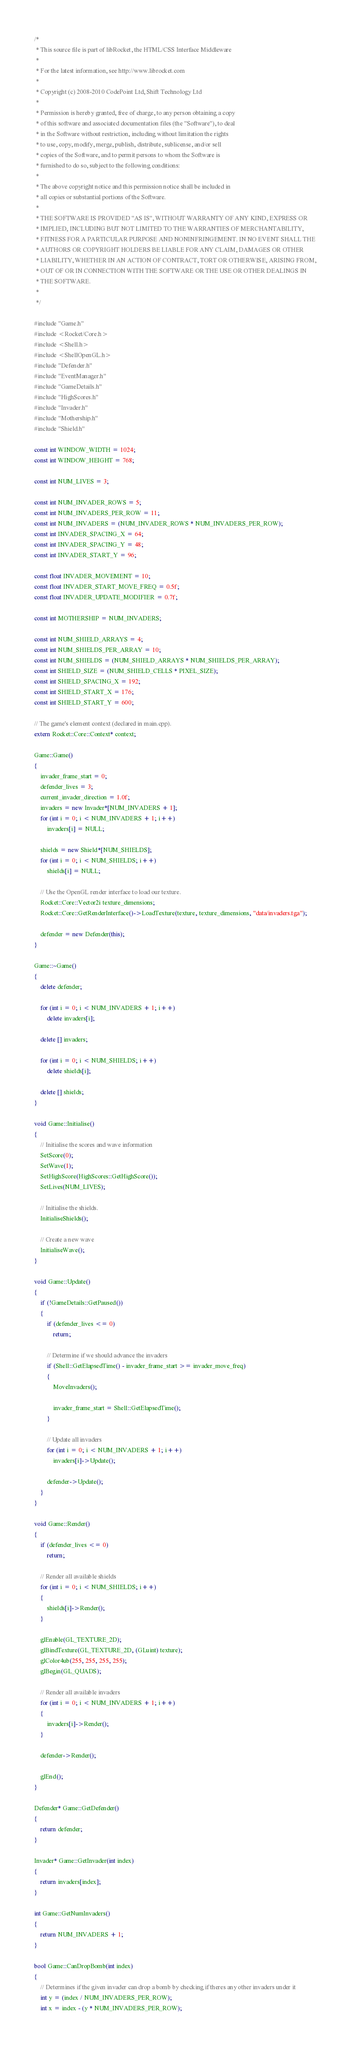<code> <loc_0><loc_0><loc_500><loc_500><_C++_>/*
 * This source file is part of libRocket, the HTML/CSS Interface Middleware
 *
 * For the latest information, see http://www.librocket.com
 *
 * Copyright (c) 2008-2010 CodePoint Ltd, Shift Technology Ltd
 *
 * Permission is hereby granted, free of charge, to any person obtaining a copy
 * of this software and associated documentation files (the "Software"), to deal
 * in the Software without restriction, including without limitation the rights
 * to use, copy, modify, merge, publish, distribute, sublicense, and/or sell
 * copies of the Software, and to permit persons to whom the Software is
 * furnished to do so, subject to the following conditions:
 *
 * The above copyright notice and this permission notice shall be included in
 * all copies or substantial portions of the Software.
 * 
 * THE SOFTWARE IS PROVIDED "AS IS", WITHOUT WARRANTY OF ANY KIND, EXPRESS OR
 * IMPLIED, INCLUDING BUT NOT LIMITED TO THE WARRANTIES OF MERCHANTABILITY,
 * FITNESS FOR A PARTICULAR PURPOSE AND NONINFRINGEMENT. IN NO EVENT SHALL THE
 * AUTHORS OR COPYRIGHT HOLDERS BE LIABLE FOR ANY CLAIM, DAMAGES OR OTHER
 * LIABILITY, WHETHER IN AN ACTION OF CONTRACT, TORT OR OTHERWISE, ARISING FROM,
 * OUT OF OR IN CONNECTION WITH THE SOFTWARE OR THE USE OR OTHER DEALINGS IN
 * THE SOFTWARE.
 *
 */

#include "Game.h"
#include <Rocket/Core.h>
#include <Shell.h>
#include <ShellOpenGL.h>
#include "Defender.h"
#include "EventManager.h"
#include "GameDetails.h"
#include "HighScores.h"
#include "Invader.h"
#include "Mothership.h"
#include "Shield.h"

const int WINDOW_WIDTH = 1024;
const int WINDOW_HEIGHT = 768;

const int NUM_LIVES = 3;

const int NUM_INVADER_ROWS = 5;
const int NUM_INVADERS_PER_ROW = 11;
const int NUM_INVADERS = (NUM_INVADER_ROWS * NUM_INVADERS_PER_ROW);
const int INVADER_SPACING_X = 64;
const int INVADER_SPACING_Y = 48;
const int INVADER_START_Y = 96;

const float INVADER_MOVEMENT = 10;
const float INVADER_START_MOVE_FREQ = 0.5f;
const float INVADER_UPDATE_MODIFIER = 0.7f;

const int MOTHERSHIP = NUM_INVADERS;

const int NUM_SHIELD_ARRAYS = 4;
const int NUM_SHIELDS_PER_ARRAY = 10;
const int NUM_SHIELDS = (NUM_SHIELD_ARRAYS * NUM_SHIELDS_PER_ARRAY);
const int SHIELD_SIZE = (NUM_SHIELD_CELLS * PIXEL_SIZE);
const int SHIELD_SPACING_X = 192;
const int SHIELD_START_X = 176;
const int SHIELD_START_Y = 600;

// The game's element context (declared in main.cpp).
extern Rocket::Core::Context* context;

Game::Game()
{
	invader_frame_start = 0;
	defender_lives = 3;	
	current_invader_direction = 1.0f;	
	invaders = new Invader*[NUM_INVADERS + 1];
	for (int i = 0; i < NUM_INVADERS + 1; i++)
		invaders[i] = NULL;	

	shields = new Shield*[NUM_SHIELDS];
	for (int i = 0; i < NUM_SHIELDS; i++)
		shields[i] = NULL;

	// Use the OpenGL render interface to load our texture.
	Rocket::Core::Vector2i texture_dimensions;
	Rocket::Core::GetRenderInterface()->LoadTexture(texture, texture_dimensions, "data/invaders.tga");

	defender = new Defender(this);
}

Game::~Game()
{
	delete defender;

	for (int i = 0; i < NUM_INVADERS + 1; i++)
		delete invaders[i];

	delete [] invaders;	

	for (int i = 0; i < NUM_SHIELDS; i++)
		delete shields[i];

	delete [] shields;
}

void Game::Initialise()
{
	// Initialise the scores and wave information
	SetScore(0);
	SetWave(1);
	SetHighScore(HighScores::GetHighScore());
	SetLives(NUM_LIVES);

	// Initialise the shields.
	InitialiseShields();

	// Create a new wave
	InitialiseWave();
}

void Game::Update()
{
	if (!GameDetails::GetPaused())
	{
		if (defender_lives <= 0)
			return;

		// Determine if we should advance the invaders
		if (Shell::GetElapsedTime() - invader_frame_start >= invader_move_freq)
		{
			MoveInvaders();		

			invader_frame_start = Shell::GetElapsedTime();
		}

		// Update all invaders
		for (int i = 0; i < NUM_INVADERS + 1; i++)
			invaders[i]->Update();	

		defender->Update();
	}
}

void Game::Render()
{	
	if (defender_lives <= 0)
		return;

	// Render all available shields
	for (int i = 0; i < NUM_SHIELDS; i++)
	{
		shields[i]->Render();
	}

	glEnable(GL_TEXTURE_2D);
	glBindTexture(GL_TEXTURE_2D, (GLuint) texture);
	glColor4ub(255, 255, 255, 255);
	glBegin(GL_QUADS);

	// Render all available invaders
	for (int i = 0; i < NUM_INVADERS + 1; i++)
	{
		invaders[i]->Render();
	}
	
	defender->Render();

	glEnd();
}

Defender* Game::GetDefender()
{
	return defender;
}

Invader* Game::GetInvader(int index)
{
	return invaders[index];
}

int Game::GetNumInvaders()
{
	return NUM_INVADERS + 1;
}

bool Game::CanDropBomb(int index)
{
	// Determines if the given invader can drop a bomb by checking if theres any other invaders under it
	int y = (index / NUM_INVADERS_PER_ROW);
	int x = index - (y * NUM_INVADERS_PER_ROW);
</code> 